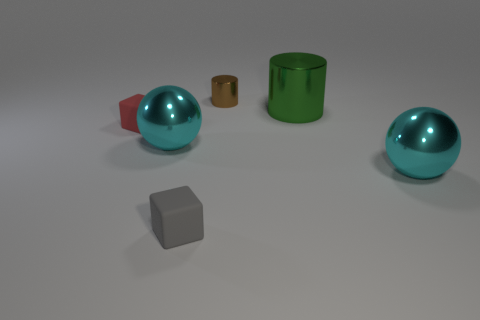Subtract all red blocks. How many blocks are left? 1 Subtract 1 balls. How many balls are left? 1 Subtract all gray spheres. How many brown cylinders are left? 1 Add 2 tiny blocks. How many objects exist? 8 Subtract all cubes. How many objects are left? 4 Subtract all yellow cylinders. Subtract all cyan balls. How many cylinders are left? 2 Subtract all tiny brown objects. Subtract all small matte cubes. How many objects are left? 3 Add 3 small blocks. How many small blocks are left? 5 Add 5 brown shiny things. How many brown shiny things exist? 6 Subtract 0 red cylinders. How many objects are left? 6 